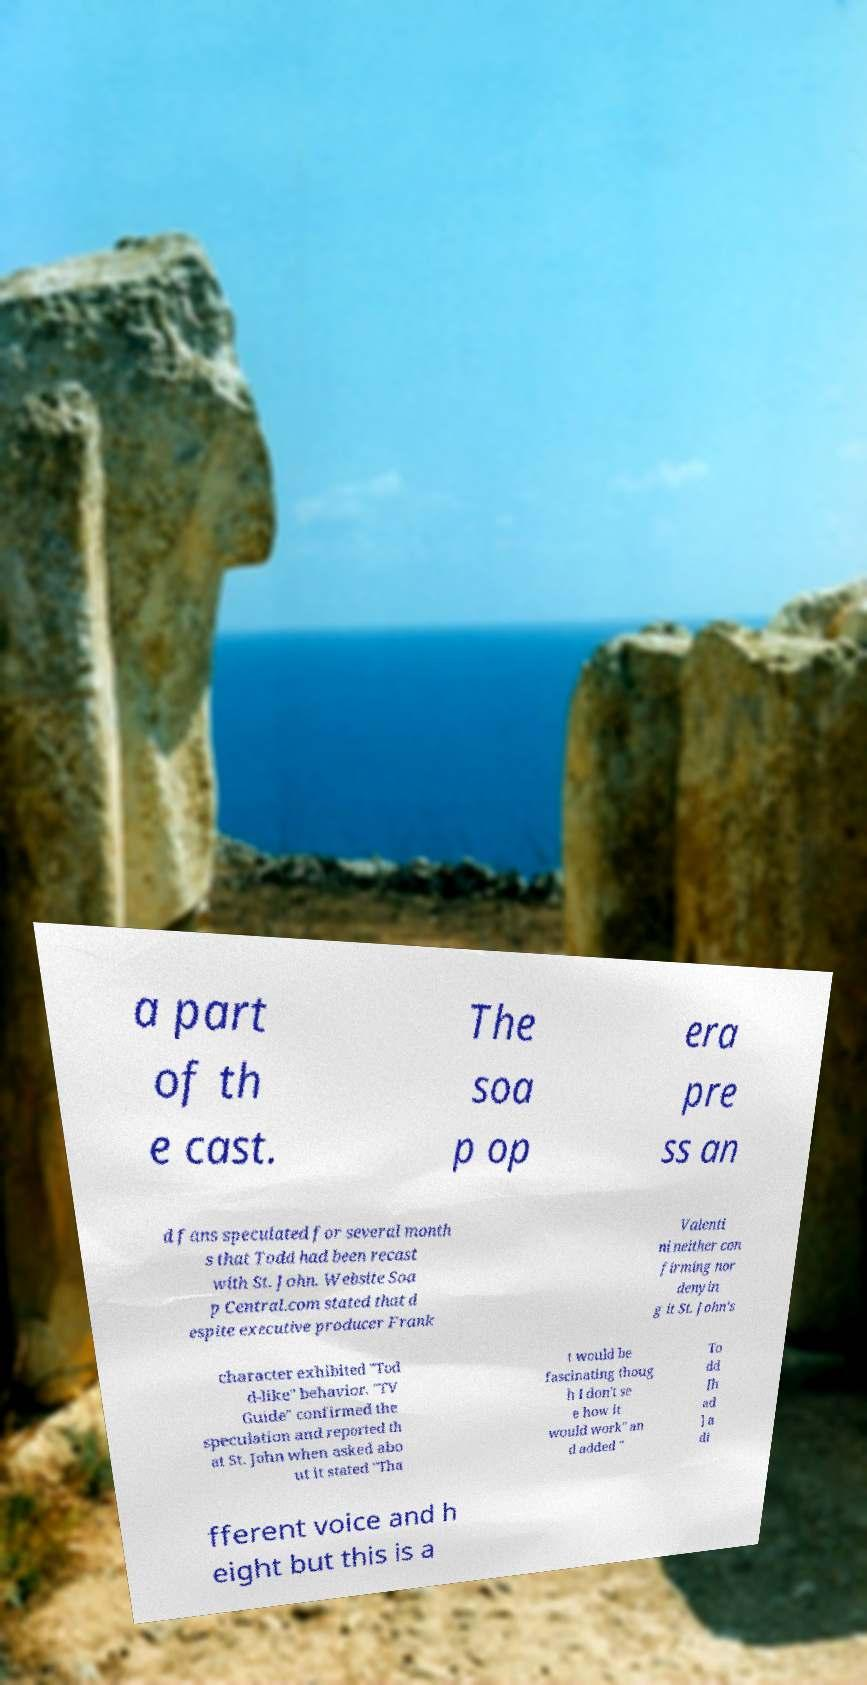I need the written content from this picture converted into text. Can you do that? a part of th e cast. The soa p op era pre ss an d fans speculated for several month s that Todd had been recast with St. John. Website Soa p Central.com stated that d espite executive producer Frank Valenti ni neither con firming nor denyin g it St. John's character exhibited "Tod d-like" behavior. "TV Guide" confirmed the speculation and reported th at St. John when asked abo ut it stated "Tha t would be fascinating thoug h I don't se e how it would work" an d added " To dd [h ad ] a di fferent voice and h eight but this is a 